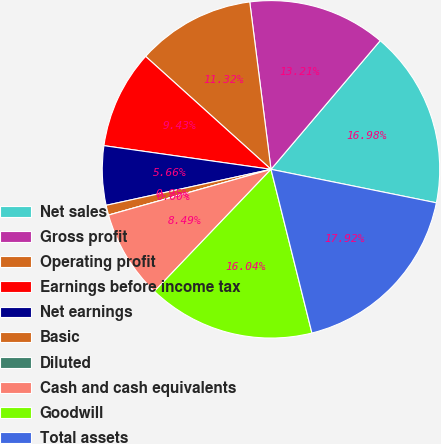Convert chart. <chart><loc_0><loc_0><loc_500><loc_500><pie_chart><fcel>Net sales<fcel>Gross profit<fcel>Operating profit<fcel>Earnings before income tax<fcel>Net earnings<fcel>Basic<fcel>Diluted<fcel>Cash and cash equivalents<fcel>Goodwill<fcel>Total assets<nl><fcel>16.98%<fcel>13.21%<fcel>11.32%<fcel>9.43%<fcel>5.66%<fcel>0.95%<fcel>0.0%<fcel>8.49%<fcel>16.04%<fcel>17.92%<nl></chart> 